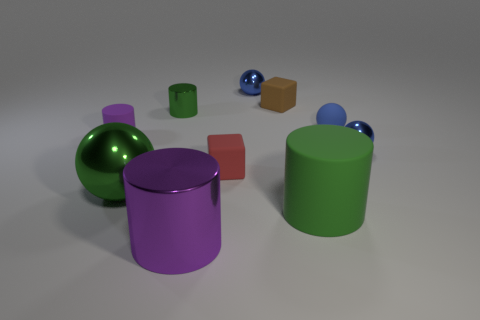What is the shape of the blue thing to the left of the green cylinder in front of the blue ball in front of the blue matte ball?
Make the answer very short. Sphere. Are there fewer large green objects than gray things?
Provide a short and direct response. No. There is a big green rubber thing; are there any big metallic balls in front of it?
Offer a terse response. No. There is a object that is both on the right side of the small purple rubber cylinder and to the left of the small green cylinder; what shape is it?
Make the answer very short. Sphere. Is there a large purple thing that has the same shape as the small brown rubber object?
Keep it short and to the point. No. Does the matte cylinder behind the large green sphere have the same size as the green cylinder that is to the right of the purple metal cylinder?
Your answer should be compact. No. Are there more metallic cylinders than yellow metal balls?
Provide a succinct answer. Yes. What number of other red cubes are made of the same material as the red cube?
Ensure brevity in your answer.  0. Is the tiny blue rubber thing the same shape as the big purple object?
Make the answer very short. No. There is a purple cylinder in front of the cube that is to the left of the metal ball behind the small purple cylinder; what size is it?
Ensure brevity in your answer.  Large. 